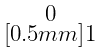Convert formula to latex. <formula><loc_0><loc_0><loc_500><loc_500>\begin{smallmatrix} 0 \\ [ 0 . 5 m m ] 1 \end{smallmatrix}</formula> 